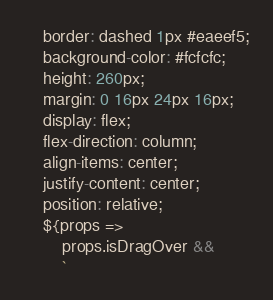Convert code to text. <code><loc_0><loc_0><loc_500><loc_500><_JavaScript_>    border: dashed 1px #eaeef5;
    background-color: #fcfcfc;
    height: 260px;
    margin: 0 16px 24px 16px;
    display: flex;
    flex-direction: column;
    align-items: center;
    justify-content: center;
    position: relative;
    ${props =>
        props.isDragOver &&
        `</code> 